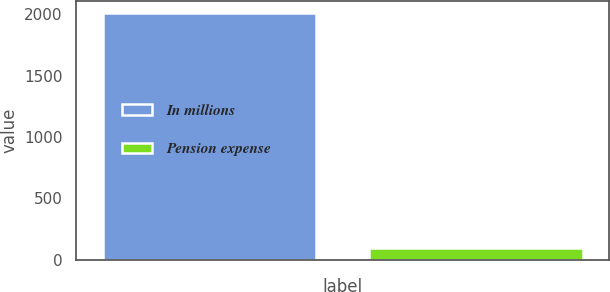<chart> <loc_0><loc_0><loc_500><loc_500><bar_chart><fcel>In millions<fcel>Pension expense<nl><fcel>2007<fcel>98<nl></chart> 